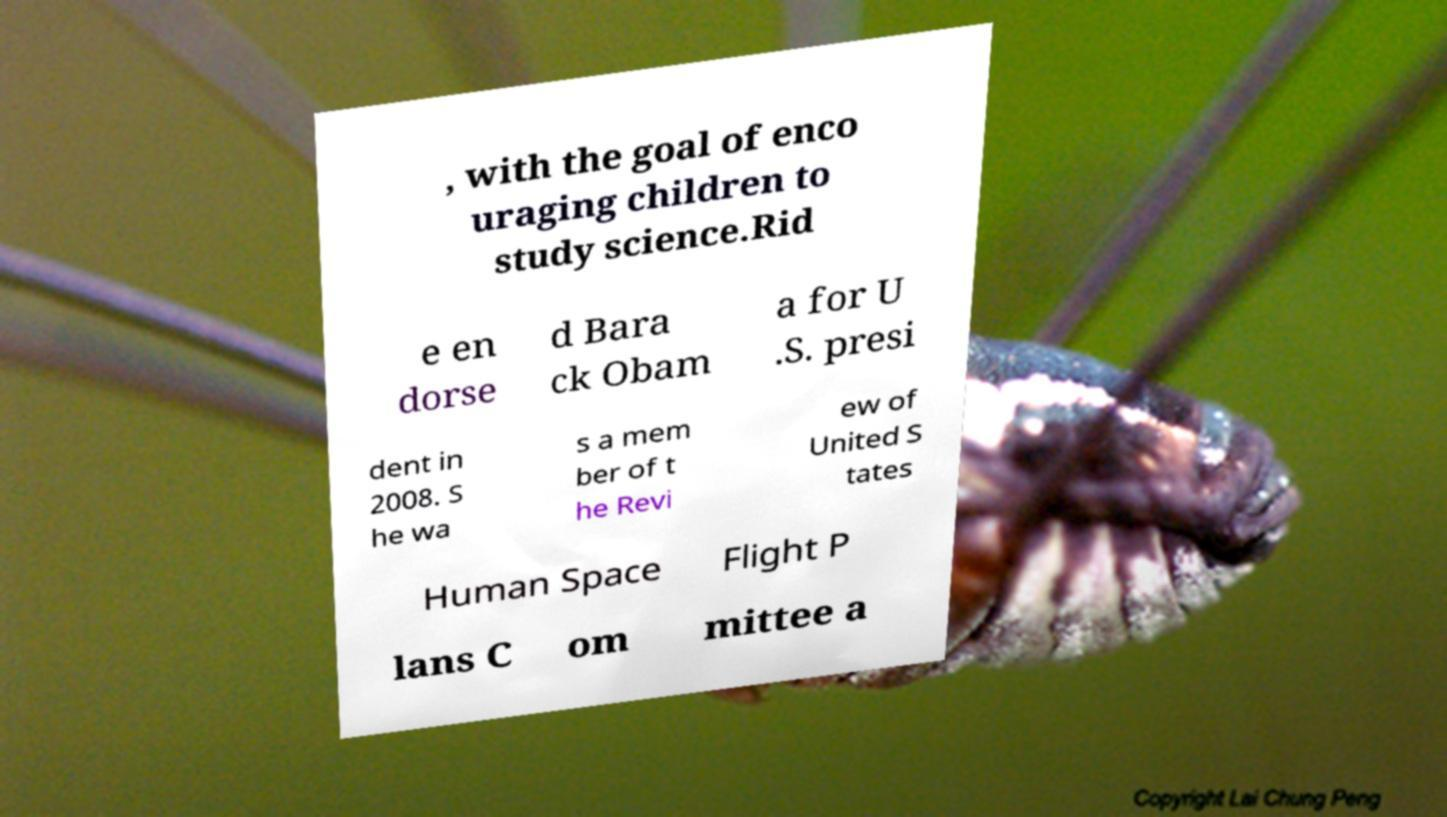Please identify and transcribe the text found in this image. , with the goal of enco uraging children to study science.Rid e en dorse d Bara ck Obam a for U .S. presi dent in 2008. S he wa s a mem ber of t he Revi ew of United S tates Human Space Flight P lans C om mittee a 